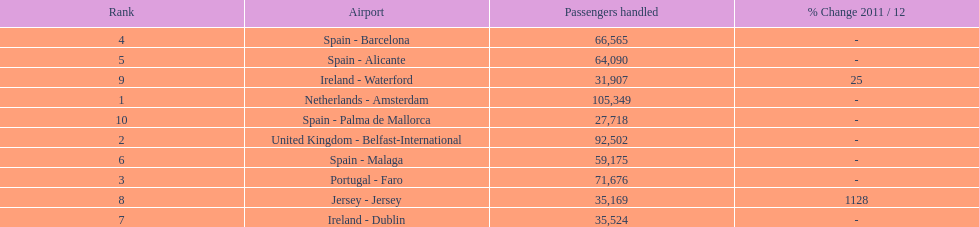What are the names of all the airports? Netherlands - Amsterdam, United Kingdom - Belfast-International, Portugal - Faro, Spain - Barcelona, Spain - Alicante, Spain - Malaga, Ireland - Dublin, Jersey - Jersey, Ireland - Waterford, Spain - Palma de Mallorca. Of these, what are all the passenger counts? 105,349, 92,502, 71,676, 66,565, 64,090, 59,175, 35,524, 35,169, 31,907, 27,718. Of these, which airport had more passengers than the united kingdom? Netherlands - Amsterdam. 